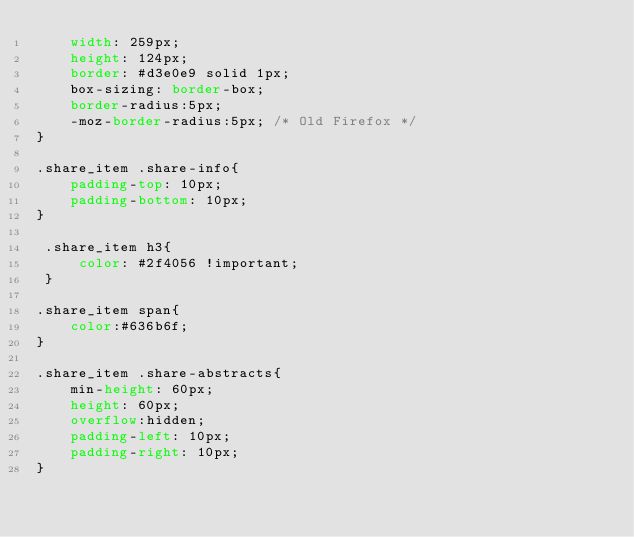<code> <loc_0><loc_0><loc_500><loc_500><_CSS_>    width: 259px;
    height: 124px;
    border: #d3e0e9 solid 1px;
    box-sizing: border-box;
    border-radius:5px;
    -moz-border-radius:5px; /* Old Firefox */
}

.share_item .share-info{
    padding-top: 10px;
    padding-bottom: 10px;
}

 .share_item h3{
     color: #2f4056 !important;
 }

.share_item span{
    color:#636b6f;
}

.share_item .share-abstracts{
    min-height: 60px;
    height: 60px;
    overflow:hidden;
    padding-left: 10px;
    padding-right: 10px;
}</code> 